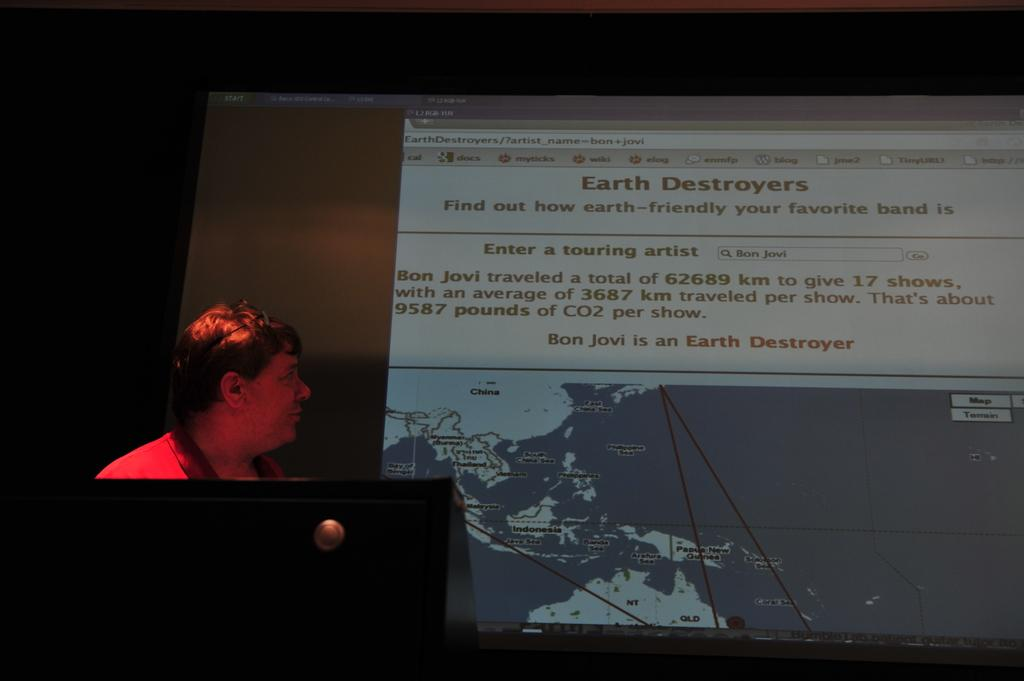What is the main subject of the image? There is a person in the image. What is the person wearing? The person is wearing a red dress. Where is the person standing in relation to the podium? The person is standing in front of a podium. What can be seen on the screen in the image? The facts do not specify what is on the screen, so we cannot answer that question definitively. How would you describe the lighting in the image? The background of the image is dark. What type of store can be seen in the background of the image? There is no store present in the image; the background is dark. What order is the person giving from the podium in the image? The facts do not specify any order being given, so we cannot answer that question definitively. 